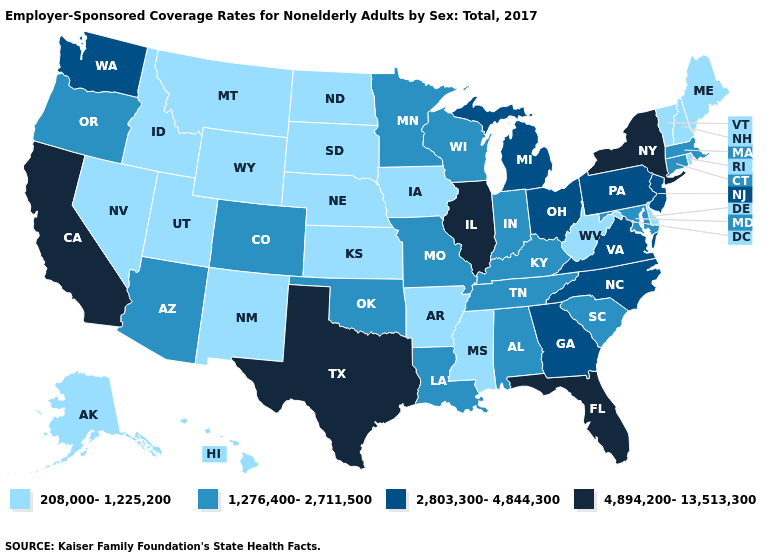What is the value of Illinois?
Give a very brief answer. 4,894,200-13,513,300. Which states have the lowest value in the USA?
Concise answer only. Alaska, Arkansas, Delaware, Hawaii, Idaho, Iowa, Kansas, Maine, Mississippi, Montana, Nebraska, Nevada, New Hampshire, New Mexico, North Dakota, Rhode Island, South Dakota, Utah, Vermont, West Virginia, Wyoming. What is the value of Texas?
Give a very brief answer. 4,894,200-13,513,300. What is the lowest value in the USA?
Short answer required. 208,000-1,225,200. What is the value of Utah?
Write a very short answer. 208,000-1,225,200. Does Kentucky have the lowest value in the South?
Keep it brief. No. Does Illinois have the highest value in the MidWest?
Be succinct. Yes. Which states have the lowest value in the Northeast?
Write a very short answer. Maine, New Hampshire, Rhode Island, Vermont. What is the highest value in states that border Maryland?
Write a very short answer. 2,803,300-4,844,300. Does Arizona have the lowest value in the USA?
Quick response, please. No. Which states have the lowest value in the USA?
Write a very short answer. Alaska, Arkansas, Delaware, Hawaii, Idaho, Iowa, Kansas, Maine, Mississippi, Montana, Nebraska, Nevada, New Hampshire, New Mexico, North Dakota, Rhode Island, South Dakota, Utah, Vermont, West Virginia, Wyoming. Does Michigan have a lower value than Hawaii?
Short answer required. No. Name the states that have a value in the range 1,276,400-2,711,500?
Give a very brief answer. Alabama, Arizona, Colorado, Connecticut, Indiana, Kentucky, Louisiana, Maryland, Massachusetts, Minnesota, Missouri, Oklahoma, Oregon, South Carolina, Tennessee, Wisconsin. Does the map have missing data?
Concise answer only. No. 